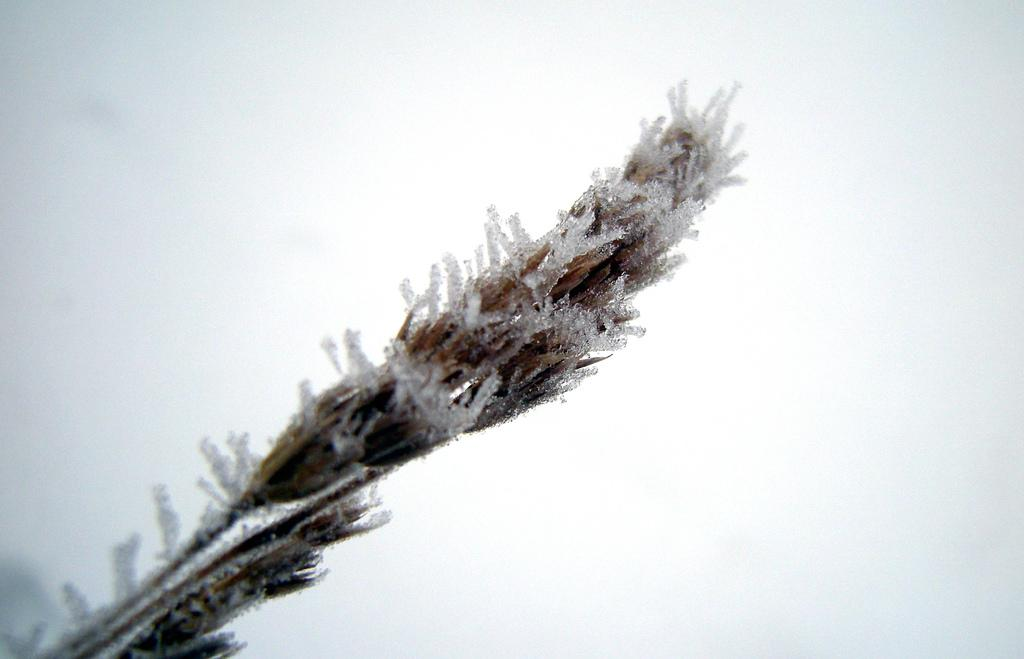What is the condition of the plant in the image? There is snow on a plant in the image. What color is the background of the image? The background of the image is white in color. What direction is the squirrel facing in the image? There is no squirrel present in the image. Is there a notebook visible in the image? There is no notebook present in the image. 